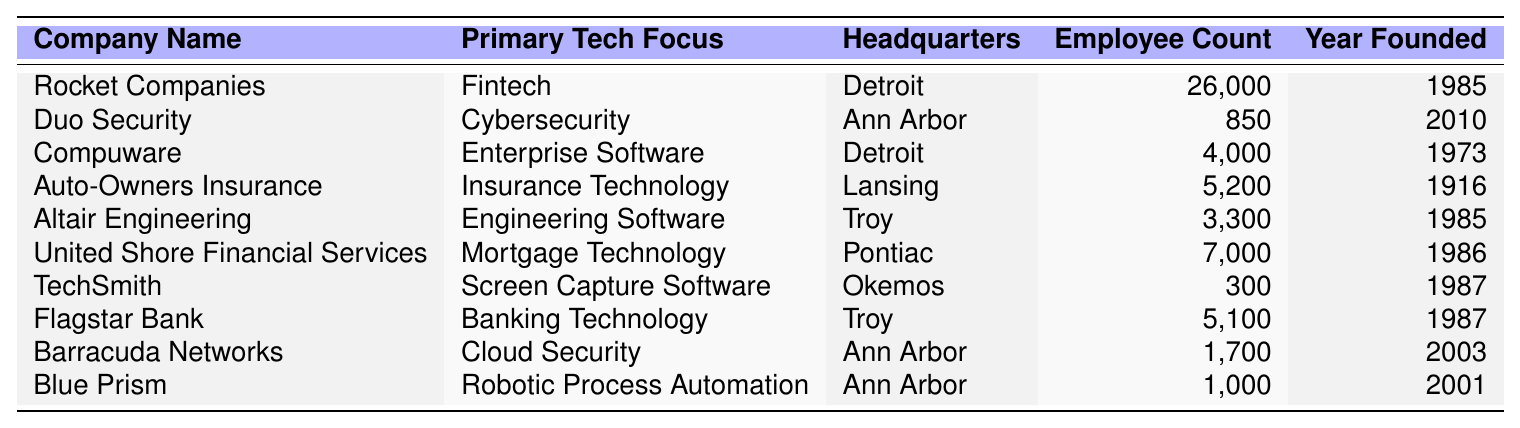What company has the highest employee count? From the table, I can see Rocket Companies listed with an employee count of 26,000, which is higher than all other companies mentioned.
Answer: Rocket Companies Which company is headquartered in Ann Arbor and focuses on cybersecurity? The table lists Duo Security under the company name, indicating that it is based in Ann Arbor and specializes in cybersecurity.
Answer: Duo Security How many companies are headquartered in Troy? By checking the table, I find that Altair Engineering and Flagstar Bank are both located in Troy, making a total of 2 companies.
Answer: 2 What is the total employee count of the companies based in Ann Arbor? I will sum the employee counts of Duo Security (850), Barracuda Networks (1,700), and Blue Prism (1,000), which gives me 850 + 1,700 + 1,000 = 3,550.
Answer: 3,550 Did any company in the table get founded after the year 2000? The table shows that Duo Security was founded in 2010, which confirms there is a company established after the year 2000.
Answer: Yes What is the average employee count of the companies listed in the table? To find the average, I will sum all employee counts: (26,000 + 850 + 4,000 + 5,200 + 3,300 + 7,000 + 300 + 5,100 + 1,700 + 1,000) = 54,450. Since there are 10 companies, I divide the total by 10, which gives 54,450 / 10 = 5,445.
Answer: 5,445 Which company has the lowest employee count and what is that count? Looking at the table, TechSmith has the lowest employee count, which is 300.
Answer: TechSmith, 300 How many companies were founded in the 1980s? Checking the founding years, I see Rocket Companies, Altair Engineering, United Shore Financial Services, and TechSmith were all established in the 1980s. This totals to 4 companies.
Answer: 4 Is there a company focused on mortgage technology in the table? United Shore Financial Services is listed with a primary focus on mortgage technology, confirming that such a company exists in the table.
Answer: Yes What is the difference in employee count between Auto-Owners Insurance and Flagstar Bank? Auto-Owners Insurance has 5,200 employees while Flagstar Bank has 5,100 employees. The difference is 5,200 - 5,100 = 100.
Answer: 100 